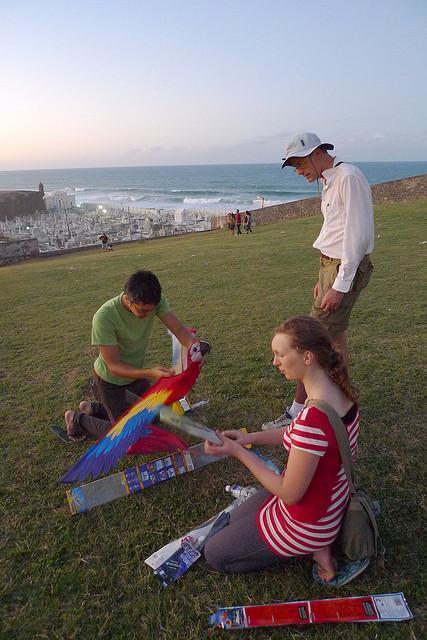How many kites are visible?
Give a very brief answer. 1. How many people are there?
Give a very brief answer. 3. 